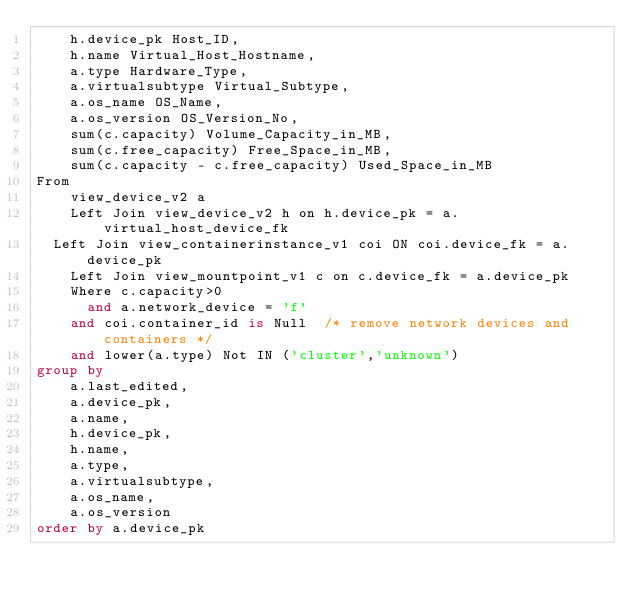<code> <loc_0><loc_0><loc_500><loc_500><_SQL_>    h.device_pk Host_ID,
    h.name Virtual_Host_Hostname,
    a.type Hardware_Type,
    a.virtualsubtype Virtual_Subtype,
    a.os_name OS_Name,
    a.os_version OS_Version_No,
    sum(c.capacity) Volume_Capacity_in_MB,
    sum(c.free_capacity) Free_Space_in_MB,
    sum(c.capacity - c.free_capacity) Used_Space_in_MB
From
    view_device_v2 a
    Left Join view_device_v2 h on h.device_pk = a.virtual_host_device_fk
	Left Join view_containerinstance_v1 coi ON coi.device_fk = a.device_pk    
    Left Join view_mountpoint_v1 c on c.device_fk = a.device_pk 
    Where c.capacity>0
	    and a.network_device = 'f' 
		and coi.container_id is Null	/* remove network devices and containers */
		and lower(a.type) Not IN ('cluster','unknown')    
group by
    a.last_edited,
    a.device_pk,
    a.name,
    h.device_pk,
    h.name,
    a.type,
    a.virtualsubtype,
    a.os_name,
    a.os_version
order by a.device_pk</code> 